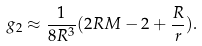Convert formula to latex. <formula><loc_0><loc_0><loc_500><loc_500>g _ { 2 } \approx \frac { 1 } { 8 R ^ { 3 } } ( 2 R M - 2 + \frac { R } { r } ) .</formula> 